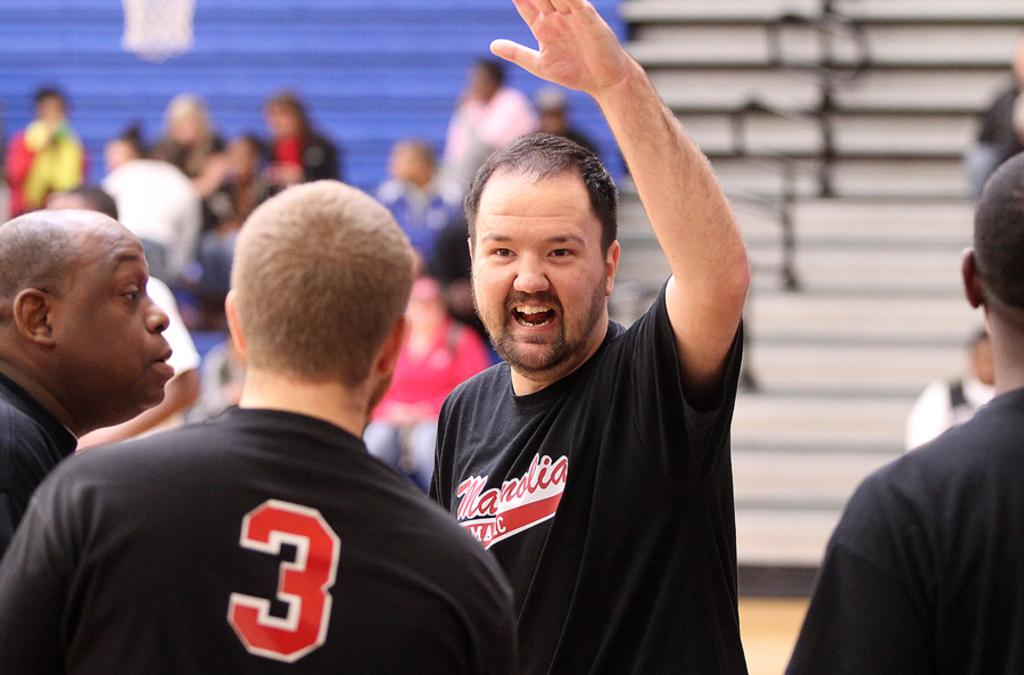What are the people in the image doing? Some people are standing, while others are sitting in the image. Can you describe the background of the image? The background of the image is blurred. What type of curtain can be seen hanging in the image? There is no curtain present in the image. How does the comb help the people in the image? There is no comb present in the image, so it cannot help the people. 